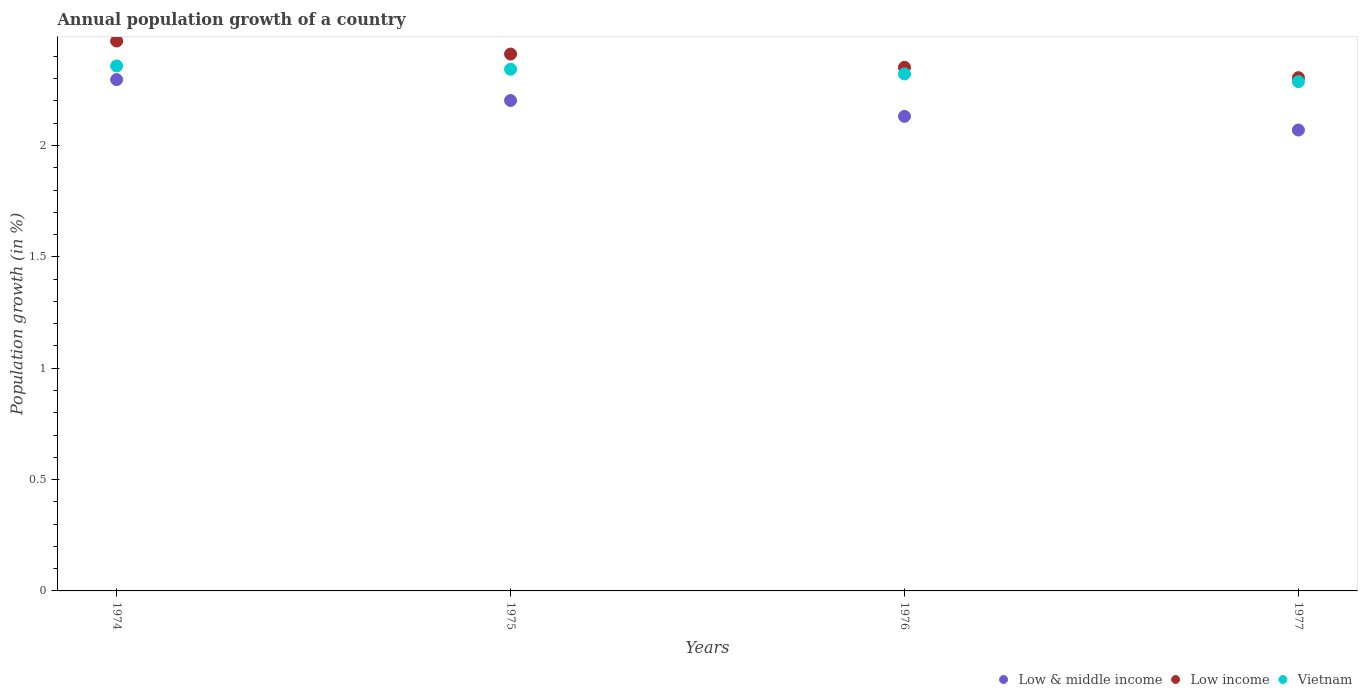What is the annual population growth in Low income in 1977?
Your response must be concise. 2.3. Across all years, what is the maximum annual population growth in Vietnam?
Offer a terse response. 2.36. Across all years, what is the minimum annual population growth in Low & middle income?
Keep it short and to the point. 2.07. In which year was the annual population growth in Vietnam maximum?
Offer a terse response. 1974. What is the total annual population growth in Vietnam in the graph?
Make the answer very short. 9.31. What is the difference between the annual population growth in Low income in 1974 and that in 1977?
Offer a very short reply. 0.16. What is the difference between the annual population growth in Vietnam in 1975 and the annual population growth in Low & middle income in 1974?
Keep it short and to the point. 0.05. What is the average annual population growth in Low & middle income per year?
Make the answer very short. 2.17. In the year 1975, what is the difference between the annual population growth in Low income and annual population growth in Low & middle income?
Offer a terse response. 0.21. In how many years, is the annual population growth in Vietnam greater than 0.7 %?
Offer a terse response. 4. What is the ratio of the annual population growth in Vietnam in 1975 to that in 1977?
Keep it short and to the point. 1.02. Is the annual population growth in Vietnam in 1974 less than that in 1977?
Keep it short and to the point. No. What is the difference between the highest and the second highest annual population growth in Vietnam?
Your answer should be compact. 0.01. What is the difference between the highest and the lowest annual population growth in Vietnam?
Your response must be concise. 0.07. Is the sum of the annual population growth in Low income in 1976 and 1977 greater than the maximum annual population growth in Low & middle income across all years?
Provide a succinct answer. Yes. Is it the case that in every year, the sum of the annual population growth in Low & middle income and annual population growth in Low income  is greater than the annual population growth in Vietnam?
Your response must be concise. Yes. Does the annual population growth in Low income monotonically increase over the years?
Offer a very short reply. No. Is the annual population growth in Low income strictly less than the annual population growth in Low & middle income over the years?
Your answer should be very brief. No. How many years are there in the graph?
Ensure brevity in your answer.  4. What is the difference between two consecutive major ticks on the Y-axis?
Ensure brevity in your answer.  0.5. Does the graph contain any zero values?
Keep it short and to the point. No. Does the graph contain grids?
Offer a very short reply. No. Where does the legend appear in the graph?
Provide a short and direct response. Bottom right. What is the title of the graph?
Your answer should be very brief. Annual population growth of a country. Does "Palau" appear as one of the legend labels in the graph?
Your response must be concise. No. What is the label or title of the Y-axis?
Your answer should be very brief. Population growth (in %). What is the Population growth (in %) in Low & middle income in 1974?
Keep it short and to the point. 2.3. What is the Population growth (in %) in Low income in 1974?
Offer a very short reply. 2.47. What is the Population growth (in %) of Vietnam in 1974?
Give a very brief answer. 2.36. What is the Population growth (in %) of Low & middle income in 1975?
Provide a succinct answer. 2.2. What is the Population growth (in %) in Low income in 1975?
Offer a very short reply. 2.41. What is the Population growth (in %) of Vietnam in 1975?
Offer a terse response. 2.34. What is the Population growth (in %) of Low & middle income in 1976?
Make the answer very short. 2.13. What is the Population growth (in %) in Low income in 1976?
Offer a very short reply. 2.35. What is the Population growth (in %) in Vietnam in 1976?
Provide a succinct answer. 2.32. What is the Population growth (in %) in Low & middle income in 1977?
Provide a succinct answer. 2.07. What is the Population growth (in %) of Low income in 1977?
Your answer should be compact. 2.3. What is the Population growth (in %) of Vietnam in 1977?
Give a very brief answer. 2.29. Across all years, what is the maximum Population growth (in %) in Low & middle income?
Offer a very short reply. 2.3. Across all years, what is the maximum Population growth (in %) of Low income?
Your response must be concise. 2.47. Across all years, what is the maximum Population growth (in %) of Vietnam?
Your answer should be compact. 2.36. Across all years, what is the minimum Population growth (in %) in Low & middle income?
Provide a short and direct response. 2.07. Across all years, what is the minimum Population growth (in %) of Low income?
Offer a very short reply. 2.3. Across all years, what is the minimum Population growth (in %) of Vietnam?
Your response must be concise. 2.29. What is the total Population growth (in %) of Low & middle income in the graph?
Make the answer very short. 8.7. What is the total Population growth (in %) in Low income in the graph?
Your answer should be compact. 9.54. What is the total Population growth (in %) of Vietnam in the graph?
Give a very brief answer. 9.31. What is the difference between the Population growth (in %) of Low & middle income in 1974 and that in 1975?
Your response must be concise. 0.09. What is the difference between the Population growth (in %) of Low income in 1974 and that in 1975?
Ensure brevity in your answer.  0.06. What is the difference between the Population growth (in %) of Vietnam in 1974 and that in 1975?
Ensure brevity in your answer.  0.01. What is the difference between the Population growth (in %) of Low & middle income in 1974 and that in 1976?
Provide a succinct answer. 0.17. What is the difference between the Population growth (in %) in Low income in 1974 and that in 1976?
Ensure brevity in your answer.  0.12. What is the difference between the Population growth (in %) of Vietnam in 1974 and that in 1976?
Offer a terse response. 0.04. What is the difference between the Population growth (in %) of Low & middle income in 1974 and that in 1977?
Your response must be concise. 0.23. What is the difference between the Population growth (in %) of Low income in 1974 and that in 1977?
Give a very brief answer. 0.16. What is the difference between the Population growth (in %) of Vietnam in 1974 and that in 1977?
Your response must be concise. 0.07. What is the difference between the Population growth (in %) of Low & middle income in 1975 and that in 1976?
Give a very brief answer. 0.07. What is the difference between the Population growth (in %) of Low income in 1975 and that in 1976?
Your answer should be very brief. 0.06. What is the difference between the Population growth (in %) in Vietnam in 1975 and that in 1976?
Provide a succinct answer. 0.02. What is the difference between the Population growth (in %) in Low & middle income in 1975 and that in 1977?
Offer a terse response. 0.13. What is the difference between the Population growth (in %) of Low income in 1975 and that in 1977?
Your response must be concise. 0.11. What is the difference between the Population growth (in %) of Vietnam in 1975 and that in 1977?
Provide a short and direct response. 0.06. What is the difference between the Population growth (in %) of Low & middle income in 1976 and that in 1977?
Your answer should be very brief. 0.06. What is the difference between the Population growth (in %) in Low income in 1976 and that in 1977?
Offer a terse response. 0.05. What is the difference between the Population growth (in %) in Vietnam in 1976 and that in 1977?
Your answer should be very brief. 0.03. What is the difference between the Population growth (in %) of Low & middle income in 1974 and the Population growth (in %) of Low income in 1975?
Keep it short and to the point. -0.11. What is the difference between the Population growth (in %) of Low & middle income in 1974 and the Population growth (in %) of Vietnam in 1975?
Make the answer very short. -0.05. What is the difference between the Population growth (in %) of Low income in 1974 and the Population growth (in %) of Vietnam in 1975?
Your response must be concise. 0.13. What is the difference between the Population growth (in %) in Low & middle income in 1974 and the Population growth (in %) in Low income in 1976?
Your answer should be very brief. -0.06. What is the difference between the Population growth (in %) of Low & middle income in 1974 and the Population growth (in %) of Vietnam in 1976?
Provide a short and direct response. -0.03. What is the difference between the Population growth (in %) of Low income in 1974 and the Population growth (in %) of Vietnam in 1976?
Your response must be concise. 0.15. What is the difference between the Population growth (in %) in Low & middle income in 1974 and the Population growth (in %) in Low income in 1977?
Your answer should be very brief. -0.01. What is the difference between the Population growth (in %) in Low & middle income in 1974 and the Population growth (in %) in Vietnam in 1977?
Keep it short and to the point. 0.01. What is the difference between the Population growth (in %) in Low income in 1974 and the Population growth (in %) in Vietnam in 1977?
Offer a very short reply. 0.18. What is the difference between the Population growth (in %) of Low & middle income in 1975 and the Population growth (in %) of Low income in 1976?
Provide a succinct answer. -0.15. What is the difference between the Population growth (in %) of Low & middle income in 1975 and the Population growth (in %) of Vietnam in 1976?
Offer a very short reply. -0.12. What is the difference between the Population growth (in %) in Low income in 1975 and the Population growth (in %) in Vietnam in 1976?
Provide a succinct answer. 0.09. What is the difference between the Population growth (in %) in Low & middle income in 1975 and the Population growth (in %) in Low income in 1977?
Ensure brevity in your answer.  -0.1. What is the difference between the Population growth (in %) in Low & middle income in 1975 and the Population growth (in %) in Vietnam in 1977?
Your answer should be compact. -0.08. What is the difference between the Population growth (in %) of Low income in 1975 and the Population growth (in %) of Vietnam in 1977?
Offer a very short reply. 0.12. What is the difference between the Population growth (in %) of Low & middle income in 1976 and the Population growth (in %) of Low income in 1977?
Provide a short and direct response. -0.17. What is the difference between the Population growth (in %) of Low & middle income in 1976 and the Population growth (in %) of Vietnam in 1977?
Make the answer very short. -0.16. What is the difference between the Population growth (in %) in Low income in 1976 and the Population growth (in %) in Vietnam in 1977?
Give a very brief answer. 0.06. What is the average Population growth (in %) in Low & middle income per year?
Make the answer very short. 2.17. What is the average Population growth (in %) in Low income per year?
Your answer should be compact. 2.38. What is the average Population growth (in %) in Vietnam per year?
Offer a terse response. 2.33. In the year 1974, what is the difference between the Population growth (in %) in Low & middle income and Population growth (in %) in Low income?
Ensure brevity in your answer.  -0.17. In the year 1974, what is the difference between the Population growth (in %) in Low & middle income and Population growth (in %) in Vietnam?
Keep it short and to the point. -0.06. In the year 1974, what is the difference between the Population growth (in %) in Low income and Population growth (in %) in Vietnam?
Ensure brevity in your answer.  0.11. In the year 1975, what is the difference between the Population growth (in %) of Low & middle income and Population growth (in %) of Low income?
Your answer should be compact. -0.21. In the year 1975, what is the difference between the Population growth (in %) of Low & middle income and Population growth (in %) of Vietnam?
Keep it short and to the point. -0.14. In the year 1975, what is the difference between the Population growth (in %) in Low income and Population growth (in %) in Vietnam?
Your answer should be very brief. 0.07. In the year 1976, what is the difference between the Population growth (in %) of Low & middle income and Population growth (in %) of Low income?
Your answer should be compact. -0.22. In the year 1976, what is the difference between the Population growth (in %) in Low & middle income and Population growth (in %) in Vietnam?
Give a very brief answer. -0.19. In the year 1976, what is the difference between the Population growth (in %) of Low income and Population growth (in %) of Vietnam?
Ensure brevity in your answer.  0.03. In the year 1977, what is the difference between the Population growth (in %) in Low & middle income and Population growth (in %) in Low income?
Offer a very short reply. -0.24. In the year 1977, what is the difference between the Population growth (in %) in Low & middle income and Population growth (in %) in Vietnam?
Give a very brief answer. -0.22. In the year 1977, what is the difference between the Population growth (in %) of Low income and Population growth (in %) of Vietnam?
Offer a terse response. 0.02. What is the ratio of the Population growth (in %) in Low & middle income in 1974 to that in 1975?
Provide a succinct answer. 1.04. What is the ratio of the Population growth (in %) of Low income in 1974 to that in 1975?
Give a very brief answer. 1.02. What is the ratio of the Population growth (in %) of Low & middle income in 1974 to that in 1976?
Give a very brief answer. 1.08. What is the ratio of the Population growth (in %) of Low income in 1974 to that in 1976?
Keep it short and to the point. 1.05. What is the ratio of the Population growth (in %) in Vietnam in 1974 to that in 1976?
Offer a terse response. 1.02. What is the ratio of the Population growth (in %) in Low & middle income in 1974 to that in 1977?
Provide a succinct answer. 1.11. What is the ratio of the Population growth (in %) in Low income in 1974 to that in 1977?
Make the answer very short. 1.07. What is the ratio of the Population growth (in %) of Vietnam in 1974 to that in 1977?
Offer a terse response. 1.03. What is the ratio of the Population growth (in %) in Low & middle income in 1975 to that in 1976?
Ensure brevity in your answer.  1.03. What is the ratio of the Population growth (in %) of Low income in 1975 to that in 1976?
Ensure brevity in your answer.  1.03. What is the ratio of the Population growth (in %) of Vietnam in 1975 to that in 1976?
Your answer should be compact. 1.01. What is the ratio of the Population growth (in %) in Low & middle income in 1975 to that in 1977?
Your response must be concise. 1.06. What is the ratio of the Population growth (in %) in Low income in 1975 to that in 1977?
Your response must be concise. 1.05. What is the ratio of the Population growth (in %) in Vietnam in 1975 to that in 1977?
Your answer should be very brief. 1.02. What is the ratio of the Population growth (in %) in Low & middle income in 1976 to that in 1977?
Make the answer very short. 1.03. What is the ratio of the Population growth (in %) in Low income in 1976 to that in 1977?
Your answer should be very brief. 1.02. What is the ratio of the Population growth (in %) in Vietnam in 1976 to that in 1977?
Ensure brevity in your answer.  1.02. What is the difference between the highest and the second highest Population growth (in %) of Low & middle income?
Give a very brief answer. 0.09. What is the difference between the highest and the second highest Population growth (in %) in Low income?
Offer a very short reply. 0.06. What is the difference between the highest and the second highest Population growth (in %) of Vietnam?
Give a very brief answer. 0.01. What is the difference between the highest and the lowest Population growth (in %) in Low & middle income?
Offer a very short reply. 0.23. What is the difference between the highest and the lowest Population growth (in %) in Low income?
Your answer should be compact. 0.16. What is the difference between the highest and the lowest Population growth (in %) of Vietnam?
Your answer should be very brief. 0.07. 